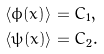Convert formula to latex. <formula><loc_0><loc_0><loc_500><loc_500>\langle \phi ( x ) \rangle & = C _ { 1 } , \\ \langle \psi ( x ) \rangle & = C _ { 2 } .</formula> 